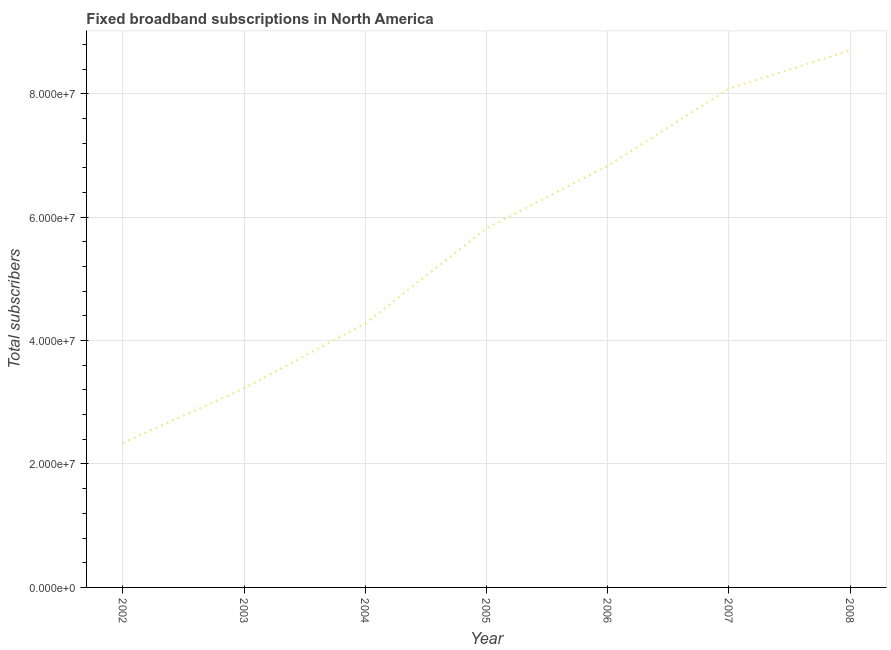What is the total number of fixed broadband subscriptions in 2004?
Ensure brevity in your answer.  4.28e+07. Across all years, what is the maximum total number of fixed broadband subscriptions?
Offer a very short reply. 8.70e+07. Across all years, what is the minimum total number of fixed broadband subscriptions?
Your answer should be compact. 2.34e+07. In which year was the total number of fixed broadband subscriptions maximum?
Provide a succinct answer. 2008. In which year was the total number of fixed broadband subscriptions minimum?
Make the answer very short. 2002. What is the sum of the total number of fixed broadband subscriptions?
Ensure brevity in your answer.  3.93e+08. What is the difference between the total number of fixed broadband subscriptions in 2005 and 2008?
Give a very brief answer. -2.88e+07. What is the average total number of fixed broadband subscriptions per year?
Make the answer very short. 5.61e+07. What is the median total number of fixed broadband subscriptions?
Provide a succinct answer. 5.82e+07. Do a majority of the years between 2005 and 2002 (inclusive) have total number of fixed broadband subscriptions greater than 80000000 ?
Offer a very short reply. Yes. What is the ratio of the total number of fixed broadband subscriptions in 2004 to that in 2007?
Your answer should be very brief. 0.53. Is the total number of fixed broadband subscriptions in 2004 less than that in 2006?
Your response must be concise. Yes. What is the difference between the highest and the second highest total number of fixed broadband subscriptions?
Make the answer very short. 6.20e+06. What is the difference between the highest and the lowest total number of fixed broadband subscriptions?
Provide a succinct answer. 6.36e+07. In how many years, is the total number of fixed broadband subscriptions greater than the average total number of fixed broadband subscriptions taken over all years?
Your answer should be compact. 4. What is the difference between two consecutive major ticks on the Y-axis?
Your response must be concise. 2.00e+07. What is the title of the graph?
Offer a very short reply. Fixed broadband subscriptions in North America. What is the label or title of the Y-axis?
Give a very brief answer. Total subscribers. What is the Total subscribers of 2002?
Your answer should be compact. 2.34e+07. What is the Total subscribers in 2003?
Provide a succinct answer. 3.23e+07. What is the Total subscribers of 2004?
Offer a terse response. 4.28e+07. What is the Total subscribers in 2005?
Give a very brief answer. 5.82e+07. What is the Total subscribers in 2006?
Make the answer very short. 6.83e+07. What is the Total subscribers of 2007?
Keep it short and to the point. 8.08e+07. What is the Total subscribers of 2008?
Provide a short and direct response. 8.70e+07. What is the difference between the Total subscribers in 2002 and 2003?
Your response must be concise. -8.86e+06. What is the difference between the Total subscribers in 2002 and 2004?
Offer a terse response. -1.94e+07. What is the difference between the Total subscribers in 2002 and 2005?
Your answer should be compact. -3.48e+07. What is the difference between the Total subscribers in 2002 and 2006?
Ensure brevity in your answer.  -4.49e+07. What is the difference between the Total subscribers in 2002 and 2007?
Your response must be concise. -5.74e+07. What is the difference between the Total subscribers in 2002 and 2008?
Make the answer very short. -6.36e+07. What is the difference between the Total subscribers in 2003 and 2004?
Provide a short and direct response. -1.05e+07. What is the difference between the Total subscribers in 2003 and 2005?
Provide a succinct answer. -2.59e+07. What is the difference between the Total subscribers in 2003 and 2006?
Offer a very short reply. -3.60e+07. What is the difference between the Total subscribers in 2003 and 2007?
Offer a very short reply. -4.86e+07. What is the difference between the Total subscribers in 2003 and 2008?
Provide a succinct answer. -5.47e+07. What is the difference between the Total subscribers in 2004 and 2005?
Offer a terse response. -1.54e+07. What is the difference between the Total subscribers in 2004 and 2006?
Your response must be concise. -2.55e+07. What is the difference between the Total subscribers in 2004 and 2007?
Provide a short and direct response. -3.80e+07. What is the difference between the Total subscribers in 2004 and 2008?
Ensure brevity in your answer.  -4.42e+07. What is the difference between the Total subscribers in 2005 and 2006?
Provide a succinct answer. -1.01e+07. What is the difference between the Total subscribers in 2005 and 2007?
Ensure brevity in your answer.  -2.26e+07. What is the difference between the Total subscribers in 2005 and 2008?
Offer a terse response. -2.88e+07. What is the difference between the Total subscribers in 2006 and 2007?
Your answer should be very brief. -1.25e+07. What is the difference between the Total subscribers in 2006 and 2008?
Make the answer very short. -1.87e+07. What is the difference between the Total subscribers in 2007 and 2008?
Your answer should be very brief. -6.20e+06. What is the ratio of the Total subscribers in 2002 to that in 2003?
Your answer should be compact. 0.72. What is the ratio of the Total subscribers in 2002 to that in 2004?
Your answer should be very brief. 0.55. What is the ratio of the Total subscribers in 2002 to that in 2005?
Offer a terse response. 0.4. What is the ratio of the Total subscribers in 2002 to that in 2006?
Your response must be concise. 0.34. What is the ratio of the Total subscribers in 2002 to that in 2007?
Make the answer very short. 0.29. What is the ratio of the Total subscribers in 2002 to that in 2008?
Offer a terse response. 0.27. What is the ratio of the Total subscribers in 2003 to that in 2004?
Offer a terse response. 0.75. What is the ratio of the Total subscribers in 2003 to that in 2005?
Your answer should be very brief. 0.55. What is the ratio of the Total subscribers in 2003 to that in 2006?
Ensure brevity in your answer.  0.47. What is the ratio of the Total subscribers in 2003 to that in 2007?
Provide a succinct answer. 0.4. What is the ratio of the Total subscribers in 2003 to that in 2008?
Your answer should be very brief. 0.37. What is the ratio of the Total subscribers in 2004 to that in 2005?
Your answer should be compact. 0.73. What is the ratio of the Total subscribers in 2004 to that in 2006?
Keep it short and to the point. 0.63. What is the ratio of the Total subscribers in 2004 to that in 2007?
Give a very brief answer. 0.53. What is the ratio of the Total subscribers in 2004 to that in 2008?
Your response must be concise. 0.49. What is the ratio of the Total subscribers in 2005 to that in 2006?
Provide a succinct answer. 0.85. What is the ratio of the Total subscribers in 2005 to that in 2007?
Provide a succinct answer. 0.72. What is the ratio of the Total subscribers in 2005 to that in 2008?
Ensure brevity in your answer.  0.67. What is the ratio of the Total subscribers in 2006 to that in 2007?
Your answer should be compact. 0.84. What is the ratio of the Total subscribers in 2006 to that in 2008?
Your response must be concise. 0.79. What is the ratio of the Total subscribers in 2007 to that in 2008?
Make the answer very short. 0.93. 